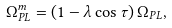Convert formula to latex. <formula><loc_0><loc_0><loc_500><loc_500>\Omega _ { P L } ^ { m } = \left ( { 1 - \lambda \cos \tau } \right ) \Omega _ { P L } ,</formula> 